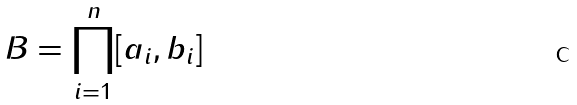Convert formula to latex. <formula><loc_0><loc_0><loc_500><loc_500>B = \prod _ { i = 1 } ^ { n } [ a _ { i } , b _ { i } ]</formula> 